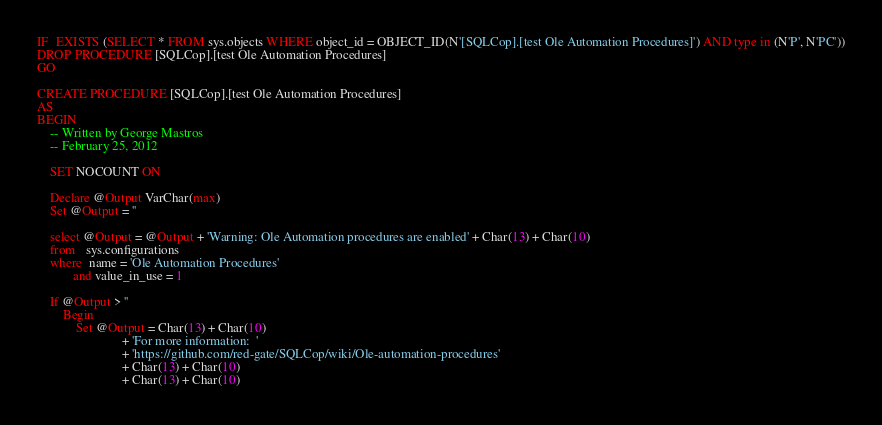Convert code to text. <code><loc_0><loc_0><loc_500><loc_500><_SQL_>IF  EXISTS (SELECT * FROM sys.objects WHERE object_id = OBJECT_ID(N'[SQLCop].[test Ole Automation Procedures]') AND type in (N'P', N'PC'))
DROP PROCEDURE [SQLCop].[test Ole Automation Procedures]
GO

CREATE PROCEDURE [SQLCop].[test Ole Automation Procedures]
AS
BEGIN
    -- Written by George Mastros
    -- February 25, 2012

    SET NOCOUNT ON

    Declare @Output VarChar(max)
    Set @Output = ''

    select @Output = @Output + 'Warning: Ole Automation procedures are enabled' + Char(13) + Char(10)
    from   sys.configurations
    where  name = 'Ole Automation Procedures'
           and value_in_use = 1

    If @Output > ''
        Begin
            Set @Output = Char(13) + Char(10)
                          + 'For more information:  '
                          + 'https://github.com/red-gate/SQLCop/wiki/Ole-automation-procedures'
                          + Char(13) + Char(10)
                          + Char(13) + Char(10)</code> 